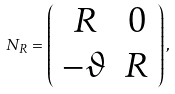<formula> <loc_0><loc_0><loc_500><loc_500>N _ { R } = \left ( \begin{array} { c c } R & 0 \\ - { \vartheta } & R \end{array} \right ) ,</formula> 